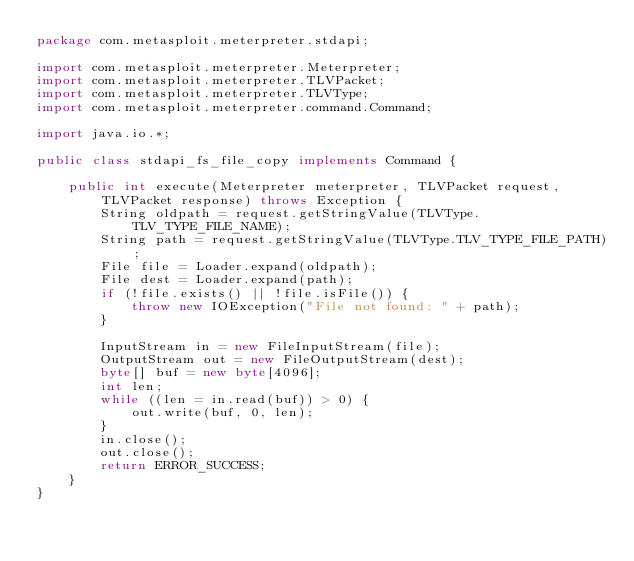<code> <loc_0><loc_0><loc_500><loc_500><_Java_>package com.metasploit.meterpreter.stdapi;

import com.metasploit.meterpreter.Meterpreter;
import com.metasploit.meterpreter.TLVPacket;
import com.metasploit.meterpreter.TLVType;
import com.metasploit.meterpreter.command.Command;

import java.io.*;

public class stdapi_fs_file_copy implements Command {

    public int execute(Meterpreter meterpreter, TLVPacket request, TLVPacket response) throws Exception {
        String oldpath = request.getStringValue(TLVType.TLV_TYPE_FILE_NAME);
        String path = request.getStringValue(TLVType.TLV_TYPE_FILE_PATH);
        File file = Loader.expand(oldpath);
        File dest = Loader.expand(path);
        if (!file.exists() || !file.isFile()) {
            throw new IOException("File not found: " + path);
        }

        InputStream in = new FileInputStream(file);
        OutputStream out = new FileOutputStream(dest);
        byte[] buf = new byte[4096];
        int len;
        while ((len = in.read(buf)) > 0) {
            out.write(buf, 0, len);
        }
        in.close();
        out.close();
        return ERROR_SUCCESS;
    }
}
</code> 